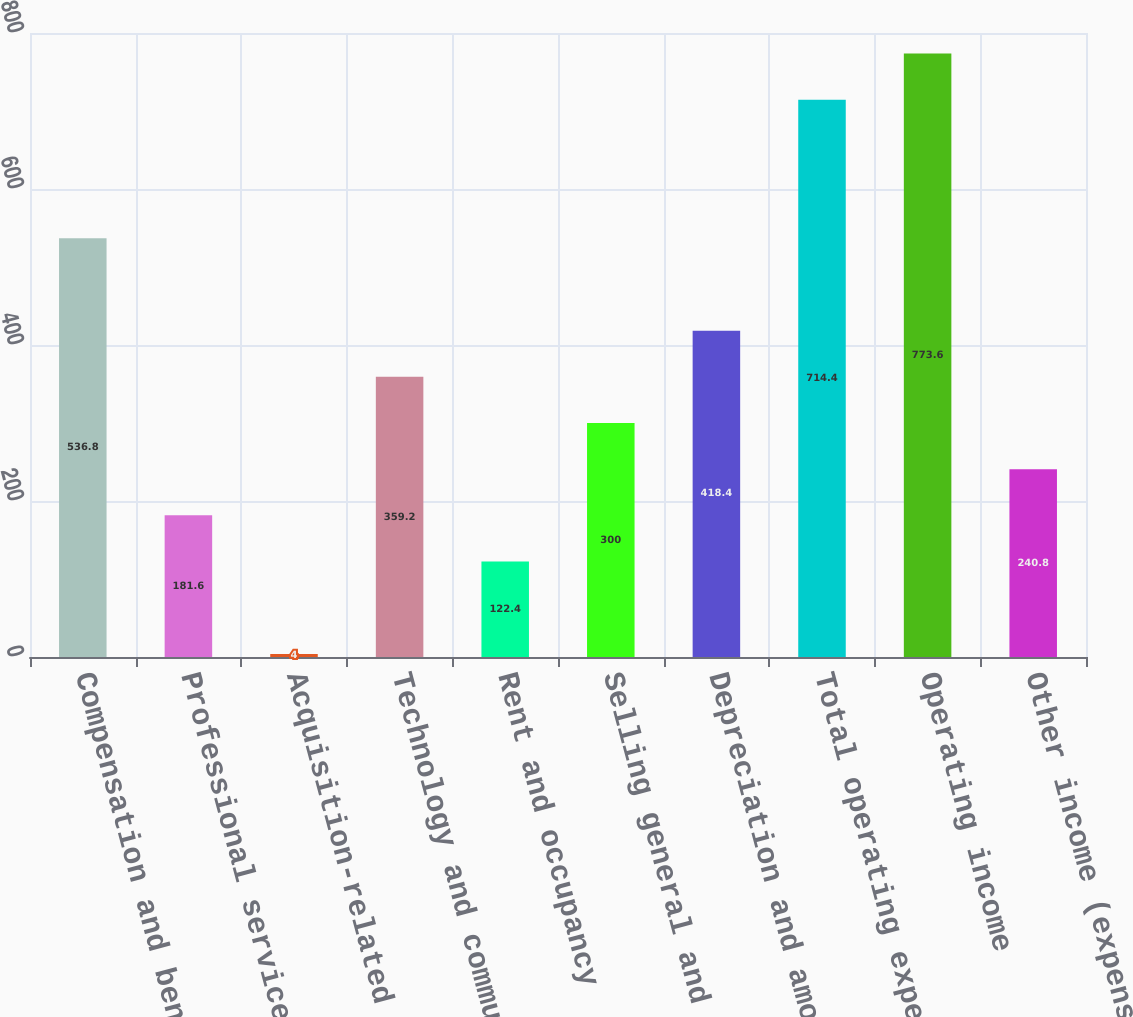Convert chart to OTSL. <chart><loc_0><loc_0><loc_500><loc_500><bar_chart><fcel>Compensation and benefits<fcel>Professional services<fcel>Acquisition-related<fcel>Technology and communication<fcel>Rent and occupancy<fcel>Selling general and<fcel>Depreciation and amortization<fcel>Total operating expenses T<fcel>Operating income<fcel>Other income (expense) net (1)<nl><fcel>536.8<fcel>181.6<fcel>4<fcel>359.2<fcel>122.4<fcel>300<fcel>418.4<fcel>714.4<fcel>773.6<fcel>240.8<nl></chart> 